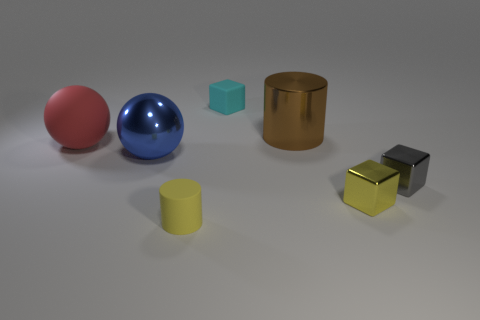Are there fewer tiny gray shiny cubes than cyan metallic things?
Your answer should be compact. No. There is a block that is both in front of the matte ball and behind the tiny yellow metal object; what size is it?
Your response must be concise. Small. How big is the shiny thing on the left side of the small yellow object left of the tiny rubber object that is behind the rubber sphere?
Your answer should be compact. Large. The yellow metal block is what size?
Your answer should be compact. Small. Is there any other thing that is the same material as the brown thing?
Provide a succinct answer. Yes. There is a yellow object to the right of the cube that is behind the large metallic cylinder; are there any cyan matte objects in front of it?
Your response must be concise. No. How many tiny things are purple shiny spheres or metal balls?
Your answer should be very brief. 0. Is there anything else of the same color as the large rubber object?
Your answer should be compact. No. There is a yellow shiny block that is left of the gray shiny object; is its size the same as the cyan cube?
Provide a short and direct response. Yes. What color is the big metallic object in front of the big thing that is behind the ball left of the big blue ball?
Provide a succinct answer. Blue. 